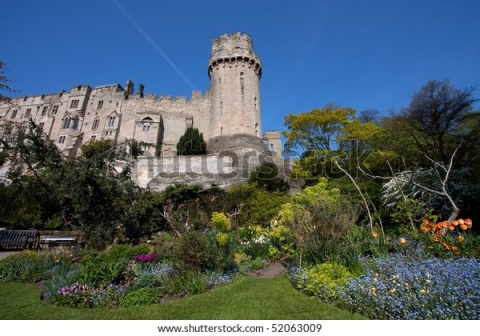Create a whimsical story about the garden gnomes living in this garden. Once upon a time, in the magical garden of a grand castle, lived a community of charming garden gnomes. These gnomes were no ordinary inhabitants; they had a special bond with the vibrant flowers and lush shrubs that surrounded them. Every night, when the moon rose high in the sky, the gnomes would come to life, tending to the garden with their tiny tools, whispering to the plants, and ensuring everything remained in perfect harmony.

The leader of the gnomes, a wise old gnome named Thistle, had lived in the garden for centuries. Thistle's hat, adorned with small flowers, was a symbol of his deep connection with nature. He guided the younger gnomes, teaching them the ancient arts of garden magic and how to coax the brightest blooms from the soil.

One day, a terrible drought threatened the garden's beauty. The flowers wilted, and the once-lush shrubs began to dry out. The gnomes were distraught, fearing they would lose their beloved home. Thistle, with his vast knowledge and wisdom, remembered a legendary crystal hidden deep within the castle—a crystal said to possess the power to bring life back to the land.

Thistle gathered the bravest gnomes and embarked on a daring adventure through the castle's hidden passages, facing enchanted creatures and overcoming intricate puzzles. After many trials, they found the crystal, glowing with an otherworldly light. With great care, they brought it back to the garden and placed it in the heart of the flower bed.

As soon as the crystal touched the earth, a miracle occurred. The garden sprang back to life, the flowers blossomed brighter than ever, and the shrubs regained their vigor. The gnomes celebrated with a grand feast, dancing and singing under the moonlight, grateful for their rejuvenated home. From that day on, the crystal remained in the garden, a testament to the resilience and bravery of the garden gnomes, ensuring the garden's enchantment for generations to come. 